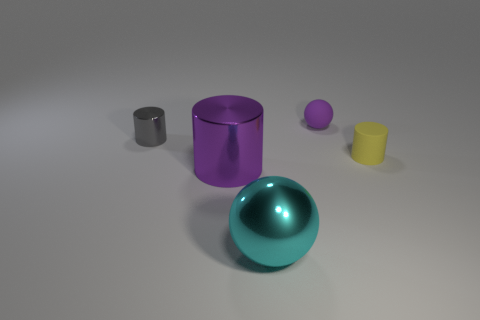How many other objects are there of the same size as the purple shiny object?
Offer a very short reply. 1. What number of gray objects are the same size as the rubber ball?
Offer a terse response. 1. How many red things are either rubber spheres or matte cylinders?
Provide a succinct answer. 0. What number of things are either tiny gray cylinders or spheres that are on the right side of the large cyan sphere?
Ensure brevity in your answer.  2. There is a tiny cylinder right of the purple matte thing; what is it made of?
Your answer should be compact. Rubber. What shape is the shiny thing that is the same size as the cyan sphere?
Provide a short and direct response. Cylinder. Is there a large cyan metallic object that has the same shape as the large purple shiny thing?
Offer a terse response. No. Does the tiny yellow object have the same material as the tiny purple object that is behind the yellow object?
Provide a succinct answer. Yes. What material is the tiny object that is in front of the cylinder on the left side of the large metallic cylinder made of?
Keep it short and to the point. Rubber. Are there more gray shiny cylinders in front of the yellow object than tiny yellow things?
Offer a terse response. No. 